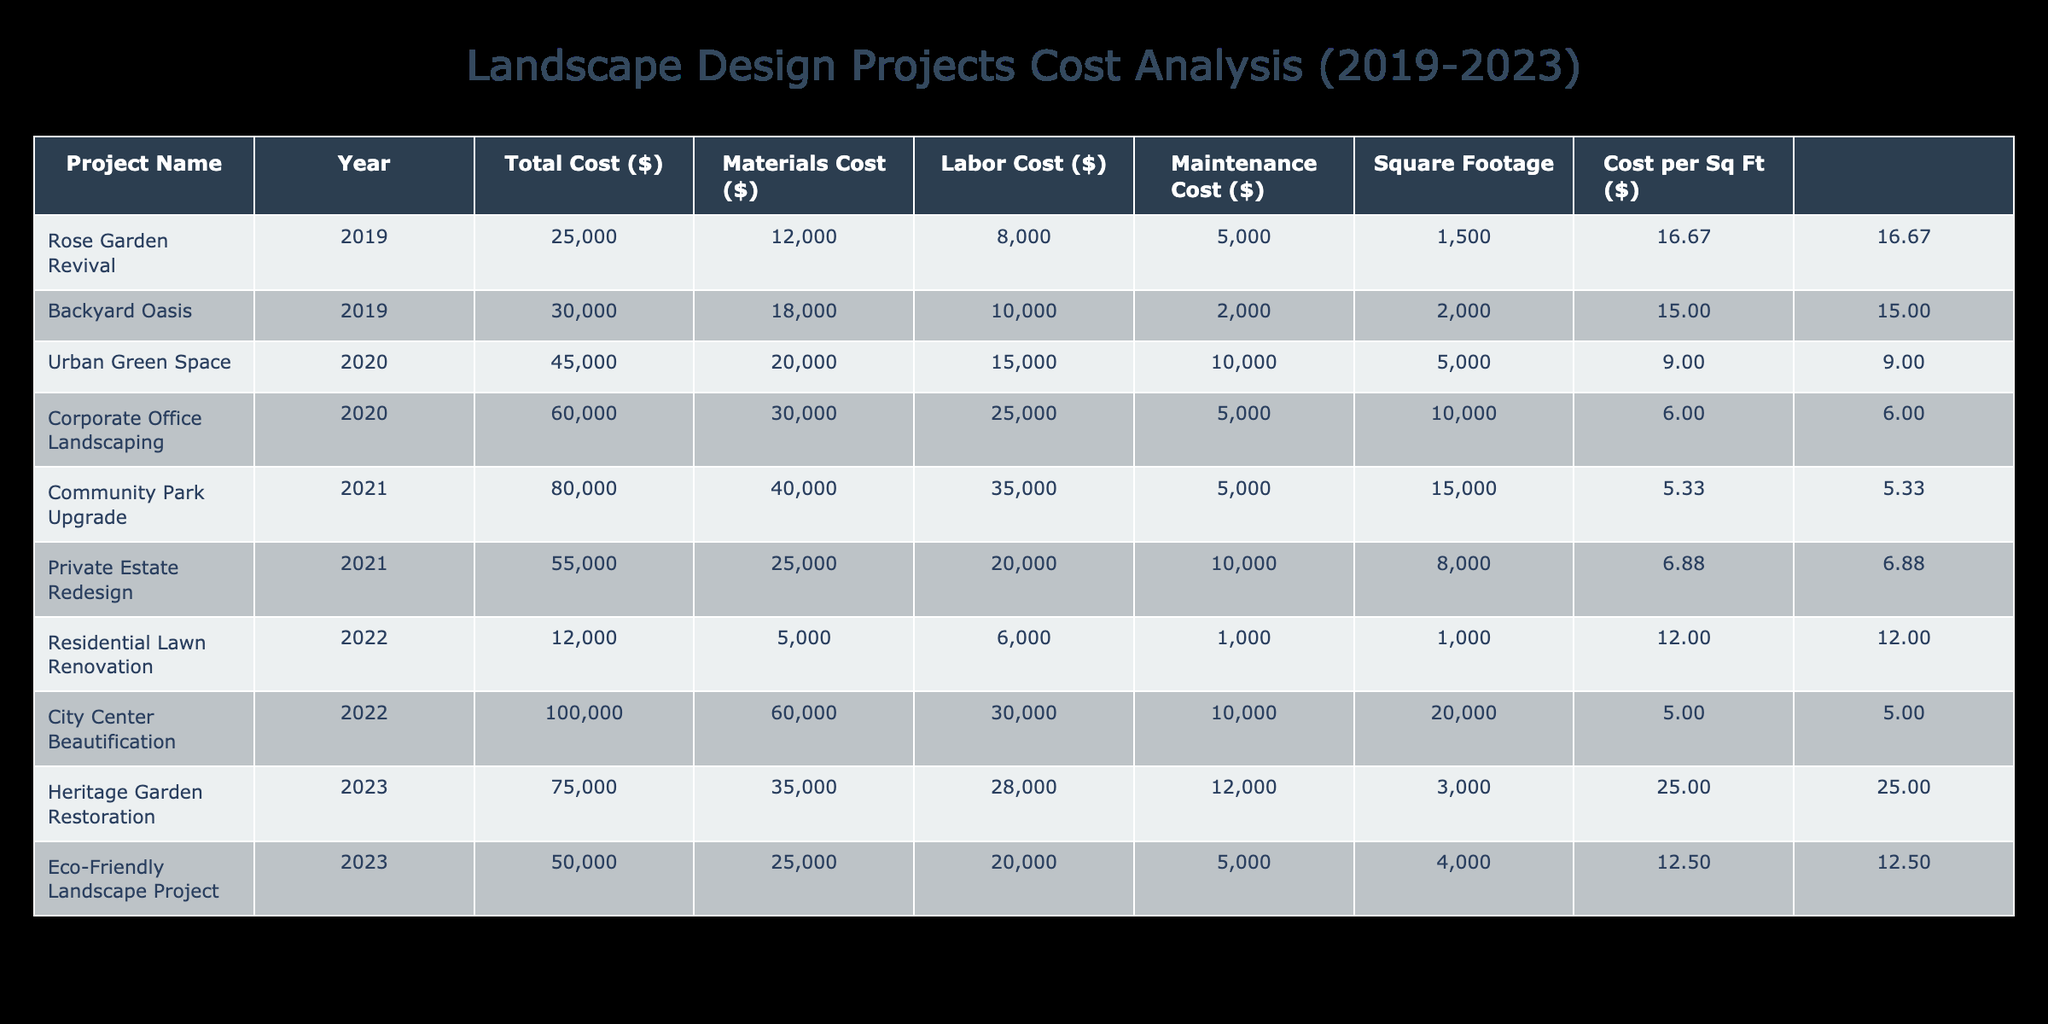What is the total cost of the Community Park Upgrade project? The table shows each project's total cost. For the Community Park Upgrade in 2021, the Total Cost is listed as 80,000.
Answer: 80,000 Which project had the highest maintenance cost? The Maintenance Cost is specified for each project. By comparing the values, the highest Maintenance Cost is 12,000 for the Heritage Garden Restoration in 2023.
Answer: Heritage Garden Restoration What is the average total cost of all projects in 2022? The total costs for 2022 are Residential Lawn Renovation (12,000) and City Center Beautification (100,000). Adding these gives 112,000. Dividing by 2, we get an average cost of 56,000.
Answer: 56,000 Did the Backyard Oasis project have a higher labor cost than the Heritage Garden Restoration project? The Labor Cost for the Backyard Oasis is 10,000 and for the Heritage Garden Restoration is 28,000. Since 10,000 is less than 28,000, the statement is false.
Answer: No Calculate the difference in total cost between the highest and lowest cost projects. The highest total cost project is City Center Beautification at 100,000, and the lowest is Residential Lawn Renovation at 12,000. The difference is calculated as 100,000 - 12,000, which equals 88,000.
Answer: 88,000 What is the total cost of projects completed in 2019? The total costs for 2019 projects are Rose Garden Revival (25,000) and Backyard Oasis (30,000). Adding these gives a total of 55,000 for 2019.
Answer: 55,000 Which year had the highest average cost per project? To find the average cost per project by year, sum the Total Costs for each year divided by the number of projects in that year: 2019 has 2 projects totaling 55,000; 2020 has 2 projects totaling 105,000; 2021 has 2 projects totaling 135,000; 2022 has 2 projects totaling 112,000; and 2023 has 2 projects totaling 125,000. The highest average is for 2021, which is 67,500.
Answer: 2021 Is the sum of materials costs for projects in 2020 greater than 50,000? The Materials Costs for 2020 projects are Urban Green Space (20,000) and Corporate Office Landscaping (30,000). The sum is 20,000 + 30,000 = 50,000, which is not greater than 50,000.
Answer: No What was the total square footage for the Eco-Friendly Landscape Project? The table specifies the square footage for each project. For the Eco-Friendly Landscape Project in 2023, the Square Footage is listed as 4,000.
Answer: 4,000 